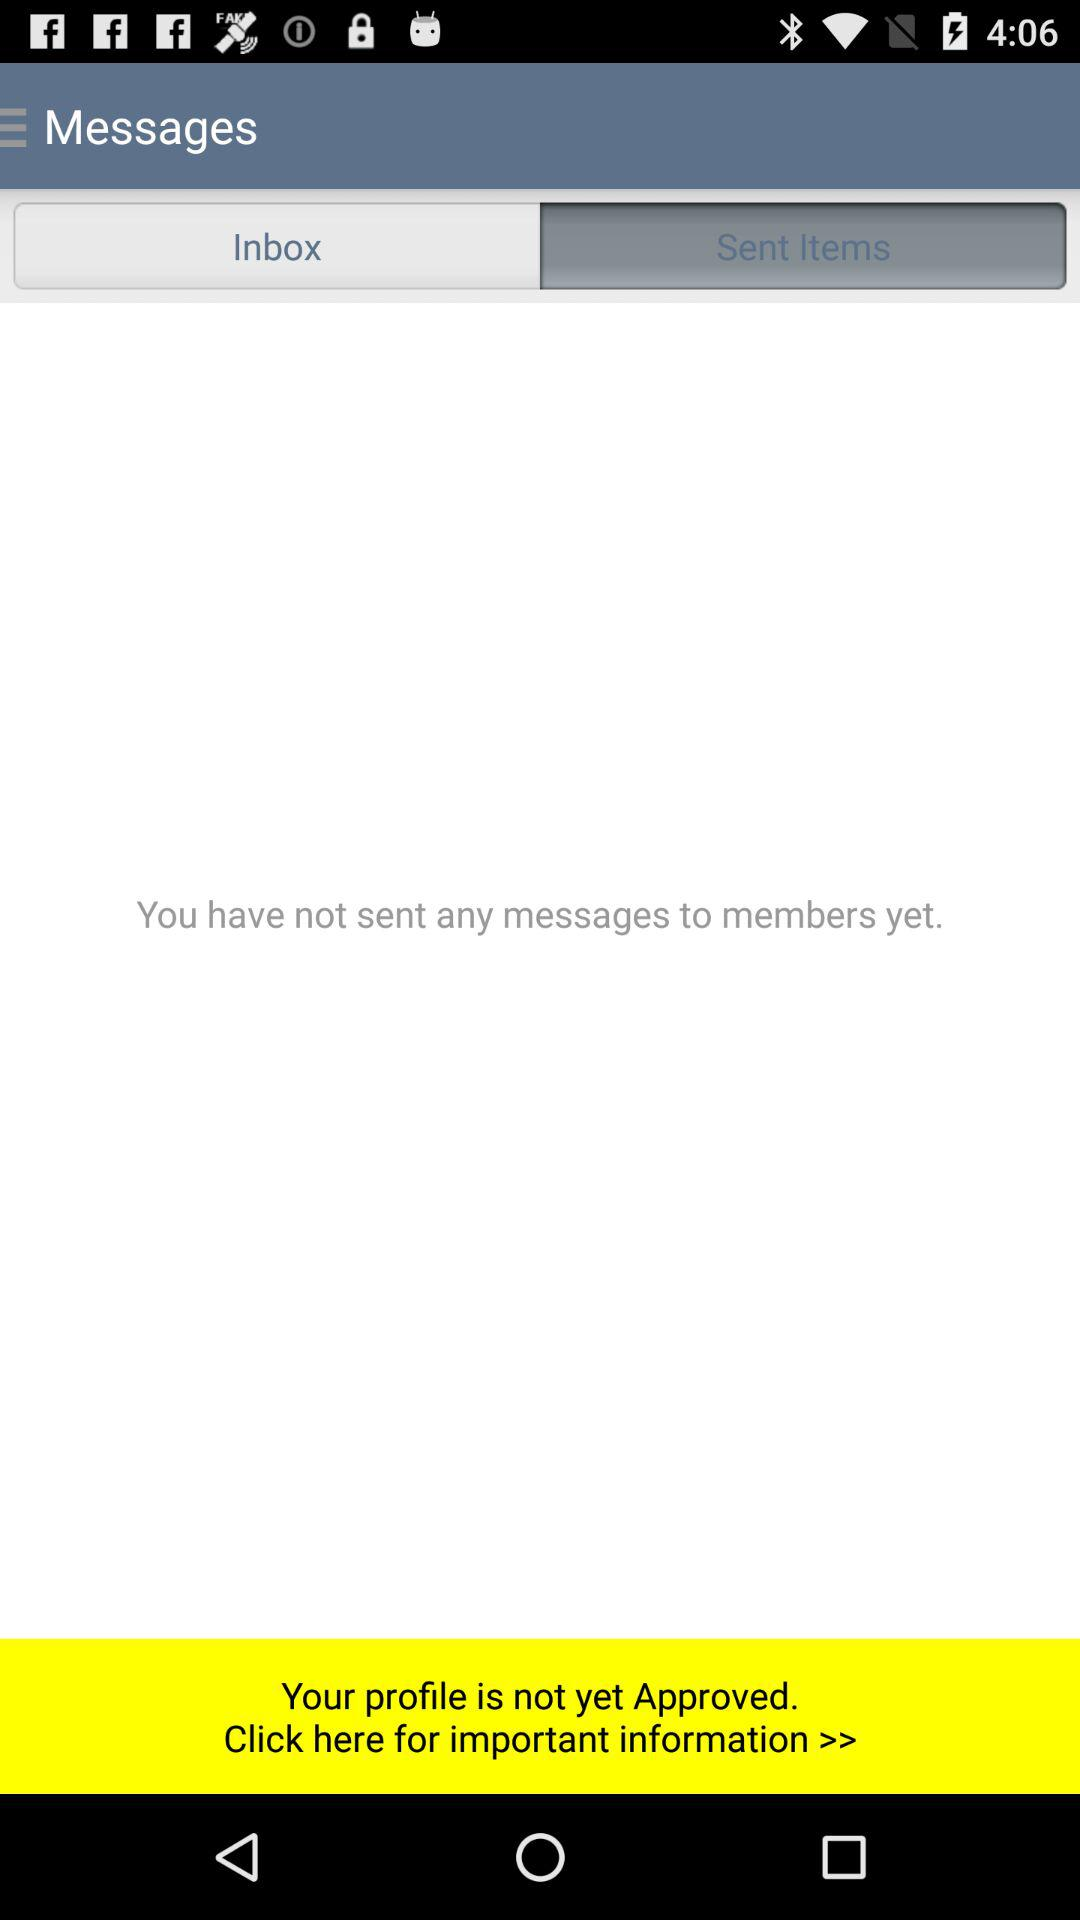How many messages have I sent?
Answer the question using a single word or phrase. 0 